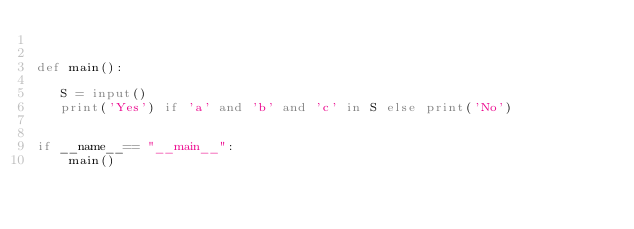<code> <loc_0><loc_0><loc_500><loc_500><_Python_>

def main():

   S = input()
   print('Yes') if 'a' and 'b' and 'c' in S else print('No')
      

if __name__== "__main__":
    main() 




</code> 